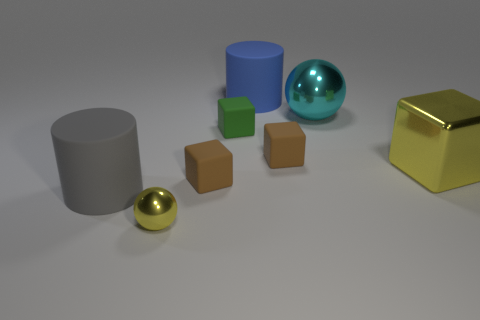Add 2 brown matte blocks. How many objects exist? 10 Subtract all yellow metallic cubes. How many cubes are left? 3 Subtract all small cyan blocks. Subtract all large metallic objects. How many objects are left? 6 Add 3 rubber objects. How many rubber objects are left? 8 Add 1 yellow matte objects. How many yellow matte objects exist? 1 Subtract all yellow spheres. How many spheres are left? 1 Subtract 1 gray cylinders. How many objects are left? 7 Subtract all cylinders. How many objects are left? 6 Subtract 1 blocks. How many blocks are left? 3 Subtract all green blocks. Subtract all green cylinders. How many blocks are left? 3 